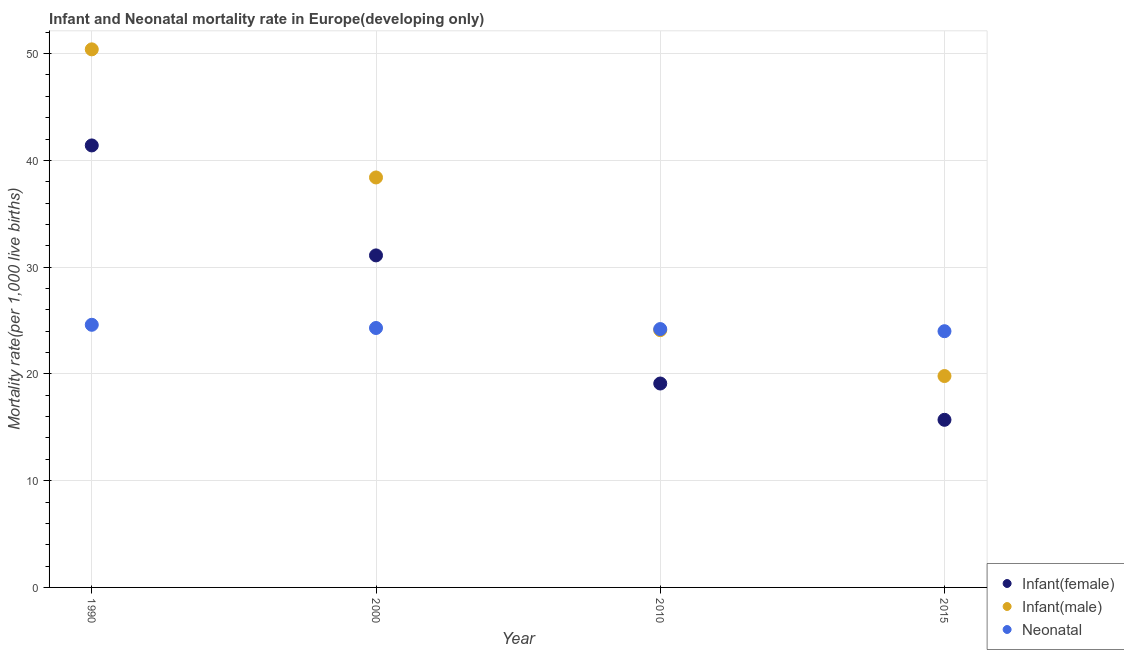Is the number of dotlines equal to the number of legend labels?
Your answer should be very brief. Yes. What is the infant mortality rate(male) in 1990?
Give a very brief answer. 50.4. Across all years, what is the maximum neonatal mortality rate?
Ensure brevity in your answer.  24.6. In which year was the infant mortality rate(female) minimum?
Provide a short and direct response. 2015. What is the total neonatal mortality rate in the graph?
Your response must be concise. 97.1. What is the difference between the infant mortality rate(male) in 2000 and that in 2010?
Keep it short and to the point. 14.3. What is the difference between the neonatal mortality rate in 2010 and the infant mortality rate(male) in 1990?
Keep it short and to the point. -26.2. What is the average infant mortality rate(female) per year?
Ensure brevity in your answer.  26.82. In how many years, is the infant mortality rate(female) greater than 44?
Your answer should be compact. 0. What is the ratio of the infant mortality rate(male) in 1990 to that in 2000?
Offer a terse response. 1.31. Is the infant mortality rate(female) in 2010 less than that in 2015?
Provide a succinct answer. No. Is the difference between the infant mortality rate(female) in 2010 and 2015 greater than the difference between the infant mortality rate(male) in 2010 and 2015?
Your answer should be very brief. No. What is the difference between the highest and the second highest infant mortality rate(male)?
Ensure brevity in your answer.  12. What is the difference between the highest and the lowest infant mortality rate(female)?
Your response must be concise. 25.7. Is it the case that in every year, the sum of the infant mortality rate(female) and infant mortality rate(male) is greater than the neonatal mortality rate?
Give a very brief answer. Yes. Are the values on the major ticks of Y-axis written in scientific E-notation?
Provide a short and direct response. No. Does the graph contain any zero values?
Provide a short and direct response. No. Does the graph contain grids?
Give a very brief answer. Yes. Where does the legend appear in the graph?
Your answer should be very brief. Bottom right. What is the title of the graph?
Your response must be concise. Infant and Neonatal mortality rate in Europe(developing only). Does "Argument" appear as one of the legend labels in the graph?
Offer a terse response. No. What is the label or title of the Y-axis?
Provide a short and direct response. Mortality rate(per 1,0 live births). What is the Mortality rate(per 1,000 live births) in Infant(female) in 1990?
Provide a short and direct response. 41.4. What is the Mortality rate(per 1,000 live births) in Infant(male) in 1990?
Your answer should be compact. 50.4. What is the Mortality rate(per 1,000 live births) in Neonatal  in 1990?
Your answer should be very brief. 24.6. What is the Mortality rate(per 1,000 live births) in Infant(female) in 2000?
Provide a succinct answer. 31.1. What is the Mortality rate(per 1,000 live births) of Infant(male) in 2000?
Provide a short and direct response. 38.4. What is the Mortality rate(per 1,000 live births) in Neonatal  in 2000?
Your answer should be very brief. 24.3. What is the Mortality rate(per 1,000 live births) in Infant(male) in 2010?
Ensure brevity in your answer.  24.1. What is the Mortality rate(per 1,000 live births) in Neonatal  in 2010?
Keep it short and to the point. 24.2. What is the Mortality rate(per 1,000 live births) in Infant(female) in 2015?
Give a very brief answer. 15.7. What is the Mortality rate(per 1,000 live births) of Infant(male) in 2015?
Make the answer very short. 19.8. What is the Mortality rate(per 1,000 live births) in Neonatal  in 2015?
Give a very brief answer. 24. Across all years, what is the maximum Mortality rate(per 1,000 live births) in Infant(female)?
Provide a short and direct response. 41.4. Across all years, what is the maximum Mortality rate(per 1,000 live births) of Infant(male)?
Your answer should be very brief. 50.4. Across all years, what is the maximum Mortality rate(per 1,000 live births) in Neonatal ?
Offer a terse response. 24.6. Across all years, what is the minimum Mortality rate(per 1,000 live births) in Infant(male)?
Keep it short and to the point. 19.8. What is the total Mortality rate(per 1,000 live births) of Infant(female) in the graph?
Offer a very short reply. 107.3. What is the total Mortality rate(per 1,000 live births) of Infant(male) in the graph?
Your answer should be compact. 132.7. What is the total Mortality rate(per 1,000 live births) in Neonatal  in the graph?
Make the answer very short. 97.1. What is the difference between the Mortality rate(per 1,000 live births) of Infant(female) in 1990 and that in 2000?
Your response must be concise. 10.3. What is the difference between the Mortality rate(per 1,000 live births) in Infant(male) in 1990 and that in 2000?
Offer a terse response. 12. What is the difference between the Mortality rate(per 1,000 live births) in Infant(female) in 1990 and that in 2010?
Give a very brief answer. 22.3. What is the difference between the Mortality rate(per 1,000 live births) of Infant(male) in 1990 and that in 2010?
Give a very brief answer. 26.3. What is the difference between the Mortality rate(per 1,000 live births) of Infant(female) in 1990 and that in 2015?
Provide a short and direct response. 25.7. What is the difference between the Mortality rate(per 1,000 live births) in Infant(male) in 1990 and that in 2015?
Your response must be concise. 30.6. What is the difference between the Mortality rate(per 1,000 live births) of Infant(female) in 2000 and that in 2010?
Keep it short and to the point. 12. What is the difference between the Mortality rate(per 1,000 live births) of Infant(male) in 2000 and that in 2010?
Provide a short and direct response. 14.3. What is the difference between the Mortality rate(per 1,000 live births) of Neonatal  in 2000 and that in 2010?
Your answer should be very brief. 0.1. What is the difference between the Mortality rate(per 1,000 live births) in Infant(male) in 2000 and that in 2015?
Provide a short and direct response. 18.6. What is the difference between the Mortality rate(per 1,000 live births) of Neonatal  in 2000 and that in 2015?
Ensure brevity in your answer.  0.3. What is the difference between the Mortality rate(per 1,000 live births) in Infant(female) in 1990 and the Mortality rate(per 1,000 live births) in Neonatal  in 2000?
Provide a succinct answer. 17.1. What is the difference between the Mortality rate(per 1,000 live births) in Infant(male) in 1990 and the Mortality rate(per 1,000 live births) in Neonatal  in 2000?
Your answer should be compact. 26.1. What is the difference between the Mortality rate(per 1,000 live births) in Infant(female) in 1990 and the Mortality rate(per 1,000 live births) in Neonatal  in 2010?
Make the answer very short. 17.2. What is the difference between the Mortality rate(per 1,000 live births) in Infant(male) in 1990 and the Mortality rate(per 1,000 live births) in Neonatal  in 2010?
Your response must be concise. 26.2. What is the difference between the Mortality rate(per 1,000 live births) in Infant(female) in 1990 and the Mortality rate(per 1,000 live births) in Infant(male) in 2015?
Your answer should be compact. 21.6. What is the difference between the Mortality rate(per 1,000 live births) of Infant(male) in 1990 and the Mortality rate(per 1,000 live births) of Neonatal  in 2015?
Give a very brief answer. 26.4. What is the difference between the Mortality rate(per 1,000 live births) of Infant(female) in 2000 and the Mortality rate(per 1,000 live births) of Neonatal  in 2015?
Provide a short and direct response. 7.1. What is the difference between the Mortality rate(per 1,000 live births) in Infant(female) in 2010 and the Mortality rate(per 1,000 live births) in Infant(male) in 2015?
Your answer should be very brief. -0.7. What is the difference between the Mortality rate(per 1,000 live births) in Infant(female) in 2010 and the Mortality rate(per 1,000 live births) in Neonatal  in 2015?
Offer a terse response. -4.9. What is the average Mortality rate(per 1,000 live births) in Infant(female) per year?
Provide a succinct answer. 26.82. What is the average Mortality rate(per 1,000 live births) in Infant(male) per year?
Your response must be concise. 33.17. What is the average Mortality rate(per 1,000 live births) in Neonatal  per year?
Keep it short and to the point. 24.27. In the year 1990, what is the difference between the Mortality rate(per 1,000 live births) of Infant(female) and Mortality rate(per 1,000 live births) of Infant(male)?
Your response must be concise. -9. In the year 1990, what is the difference between the Mortality rate(per 1,000 live births) of Infant(male) and Mortality rate(per 1,000 live births) of Neonatal ?
Your answer should be very brief. 25.8. In the year 2000, what is the difference between the Mortality rate(per 1,000 live births) of Infant(female) and Mortality rate(per 1,000 live births) of Infant(male)?
Your answer should be very brief. -7.3. In the year 2000, what is the difference between the Mortality rate(per 1,000 live births) in Infant(female) and Mortality rate(per 1,000 live births) in Neonatal ?
Offer a terse response. 6.8. In the year 2010, what is the difference between the Mortality rate(per 1,000 live births) of Infant(male) and Mortality rate(per 1,000 live births) of Neonatal ?
Offer a very short reply. -0.1. In the year 2015, what is the difference between the Mortality rate(per 1,000 live births) in Infant(female) and Mortality rate(per 1,000 live births) in Infant(male)?
Offer a very short reply. -4.1. In the year 2015, what is the difference between the Mortality rate(per 1,000 live births) of Infant(female) and Mortality rate(per 1,000 live births) of Neonatal ?
Offer a very short reply. -8.3. In the year 2015, what is the difference between the Mortality rate(per 1,000 live births) in Infant(male) and Mortality rate(per 1,000 live births) in Neonatal ?
Your answer should be very brief. -4.2. What is the ratio of the Mortality rate(per 1,000 live births) in Infant(female) in 1990 to that in 2000?
Offer a very short reply. 1.33. What is the ratio of the Mortality rate(per 1,000 live births) in Infant(male) in 1990 to that in 2000?
Offer a terse response. 1.31. What is the ratio of the Mortality rate(per 1,000 live births) in Neonatal  in 1990 to that in 2000?
Make the answer very short. 1.01. What is the ratio of the Mortality rate(per 1,000 live births) in Infant(female) in 1990 to that in 2010?
Give a very brief answer. 2.17. What is the ratio of the Mortality rate(per 1,000 live births) of Infant(male) in 1990 to that in 2010?
Your response must be concise. 2.09. What is the ratio of the Mortality rate(per 1,000 live births) of Neonatal  in 1990 to that in 2010?
Your answer should be compact. 1.02. What is the ratio of the Mortality rate(per 1,000 live births) in Infant(female) in 1990 to that in 2015?
Provide a succinct answer. 2.64. What is the ratio of the Mortality rate(per 1,000 live births) in Infant(male) in 1990 to that in 2015?
Keep it short and to the point. 2.55. What is the ratio of the Mortality rate(per 1,000 live births) of Neonatal  in 1990 to that in 2015?
Your response must be concise. 1.02. What is the ratio of the Mortality rate(per 1,000 live births) in Infant(female) in 2000 to that in 2010?
Make the answer very short. 1.63. What is the ratio of the Mortality rate(per 1,000 live births) of Infant(male) in 2000 to that in 2010?
Offer a very short reply. 1.59. What is the ratio of the Mortality rate(per 1,000 live births) of Neonatal  in 2000 to that in 2010?
Your answer should be compact. 1. What is the ratio of the Mortality rate(per 1,000 live births) in Infant(female) in 2000 to that in 2015?
Your answer should be very brief. 1.98. What is the ratio of the Mortality rate(per 1,000 live births) of Infant(male) in 2000 to that in 2015?
Your answer should be compact. 1.94. What is the ratio of the Mortality rate(per 1,000 live births) of Neonatal  in 2000 to that in 2015?
Offer a very short reply. 1.01. What is the ratio of the Mortality rate(per 1,000 live births) in Infant(female) in 2010 to that in 2015?
Provide a short and direct response. 1.22. What is the ratio of the Mortality rate(per 1,000 live births) of Infant(male) in 2010 to that in 2015?
Your answer should be very brief. 1.22. What is the ratio of the Mortality rate(per 1,000 live births) in Neonatal  in 2010 to that in 2015?
Your answer should be very brief. 1.01. What is the difference between the highest and the second highest Mortality rate(per 1,000 live births) of Infant(female)?
Offer a terse response. 10.3. What is the difference between the highest and the second highest Mortality rate(per 1,000 live births) in Neonatal ?
Provide a succinct answer. 0.3. What is the difference between the highest and the lowest Mortality rate(per 1,000 live births) in Infant(female)?
Your response must be concise. 25.7. What is the difference between the highest and the lowest Mortality rate(per 1,000 live births) of Infant(male)?
Provide a succinct answer. 30.6. 